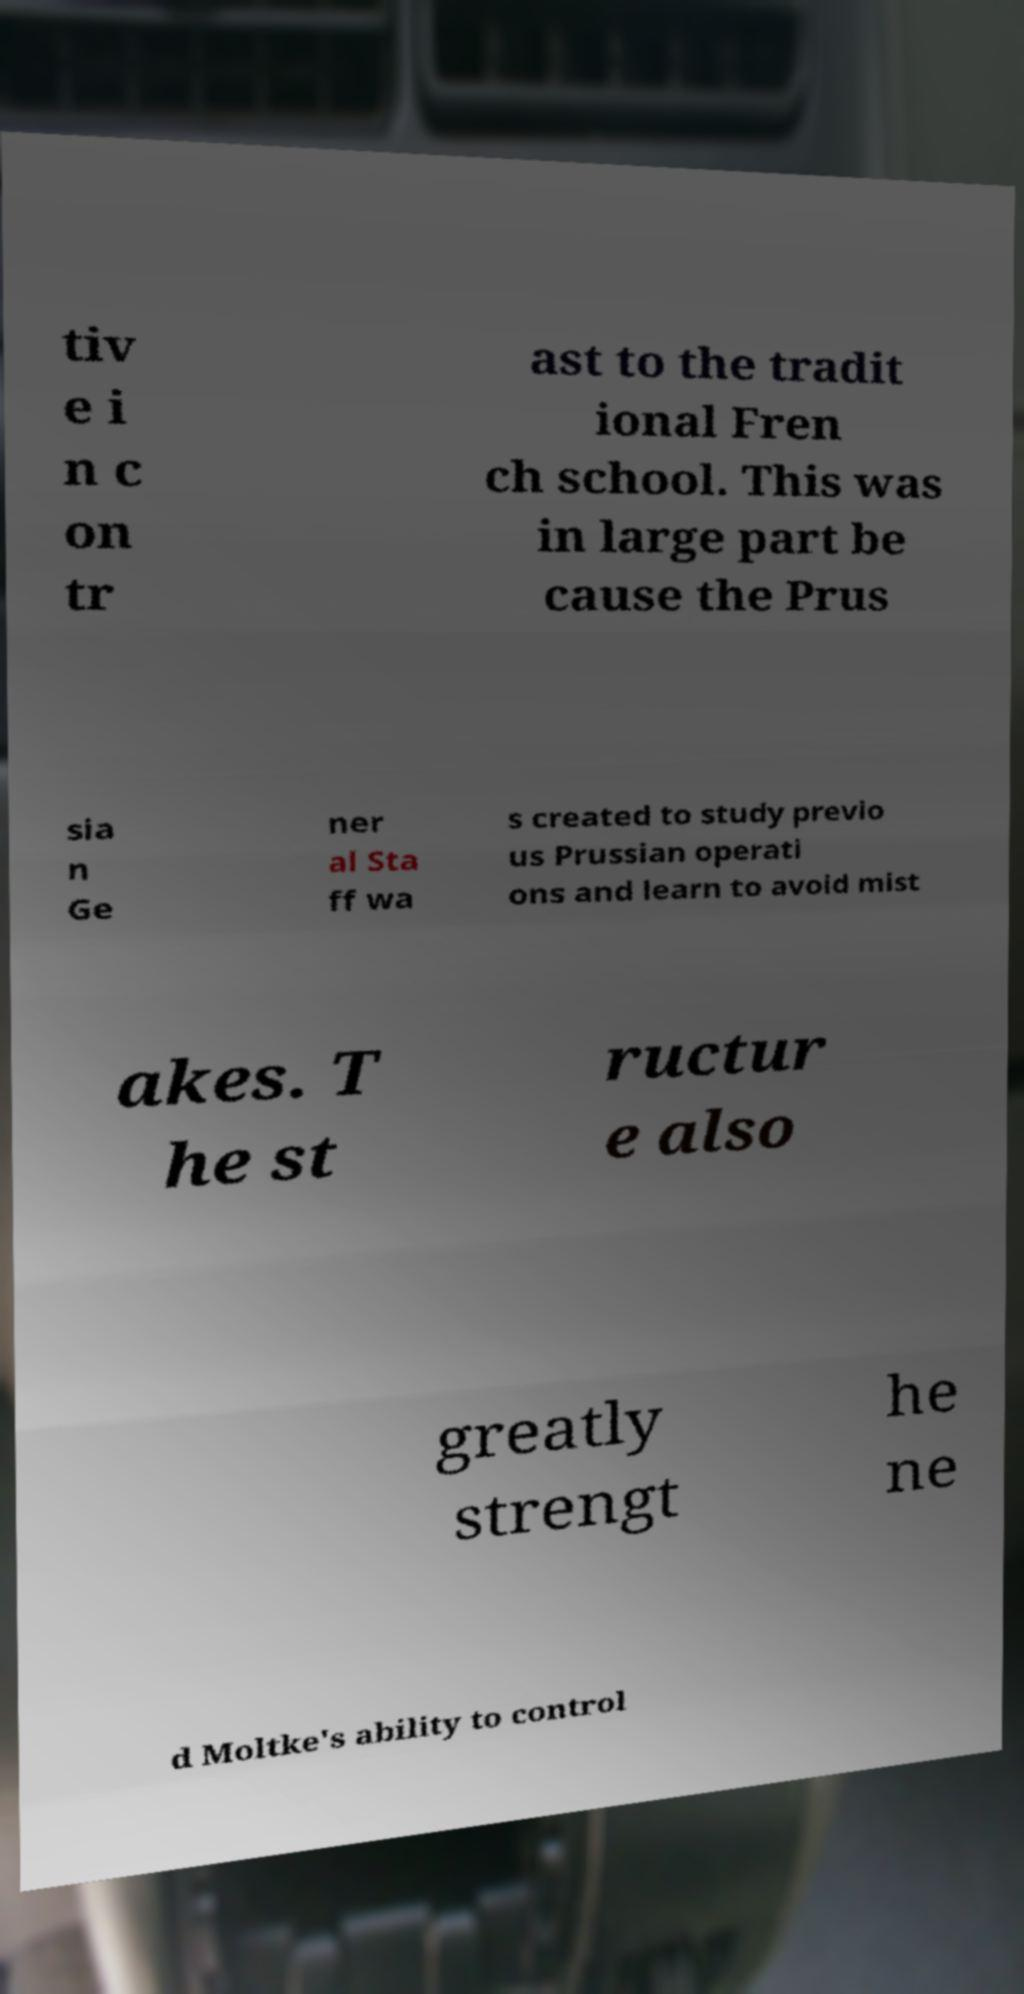Can you read and provide the text displayed in the image?This photo seems to have some interesting text. Can you extract and type it out for me? tiv e i n c on tr ast to the tradit ional Fren ch school. This was in large part be cause the Prus sia n Ge ner al Sta ff wa s created to study previo us Prussian operati ons and learn to avoid mist akes. T he st ructur e also greatly strengt he ne d Moltke's ability to control 